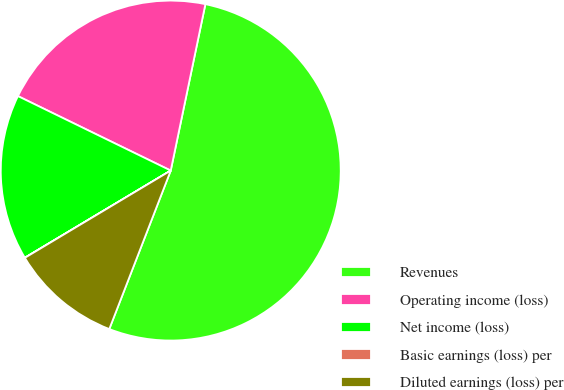Convert chart to OTSL. <chart><loc_0><loc_0><loc_500><loc_500><pie_chart><fcel>Revenues<fcel>Operating income (loss)<fcel>Net income (loss)<fcel>Basic earnings (loss) per<fcel>Diluted earnings (loss) per<nl><fcel>52.62%<fcel>21.05%<fcel>15.79%<fcel>0.01%<fcel>10.53%<nl></chart> 